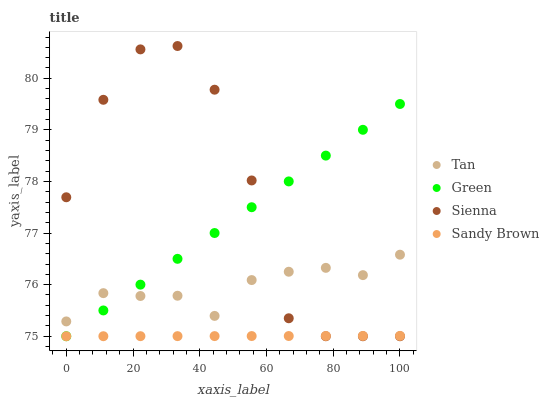Does Sandy Brown have the minimum area under the curve?
Answer yes or no. Yes. Does Sienna have the maximum area under the curve?
Answer yes or no. Yes. Does Tan have the minimum area under the curve?
Answer yes or no. No. Does Tan have the maximum area under the curve?
Answer yes or no. No. Is Green the smoothest?
Answer yes or no. Yes. Is Sienna the roughest?
Answer yes or no. Yes. Is Sandy Brown the smoothest?
Answer yes or no. No. Is Sandy Brown the roughest?
Answer yes or no. No. Does Sienna have the lowest value?
Answer yes or no. Yes. Does Tan have the lowest value?
Answer yes or no. No. Does Sienna have the highest value?
Answer yes or no. Yes. Does Tan have the highest value?
Answer yes or no. No. Is Sandy Brown less than Tan?
Answer yes or no. Yes. Is Tan greater than Sandy Brown?
Answer yes or no. Yes. Does Green intersect Sienna?
Answer yes or no. Yes. Is Green less than Sienna?
Answer yes or no. No. Is Green greater than Sienna?
Answer yes or no. No. Does Sandy Brown intersect Tan?
Answer yes or no. No. 